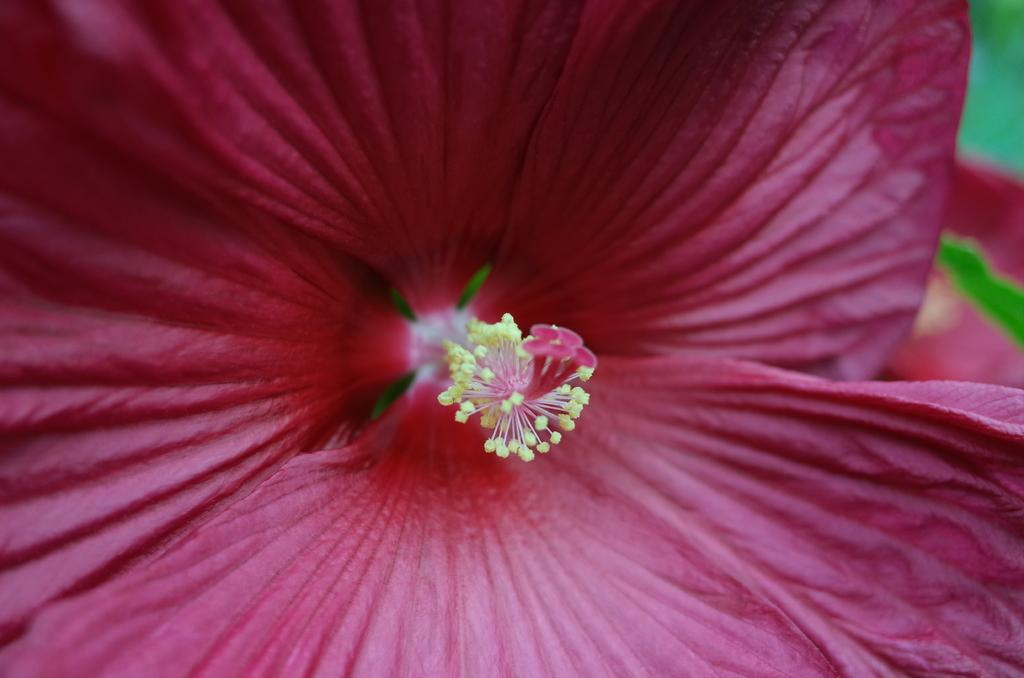What type of photographic technique is used in the image? The image is a macro shot. What color is the flower in the image? The flower in the image is pink in color. How is the background of the image depicted? The background of the image is blurred. What type of floor can be seen beneath the flower in the image? There is no floor visible in the image, as it is a macro shot focusing on the flower. Are the trousers of the photographer visible in the image? There is no indication of the photographer or their clothing in the image. 